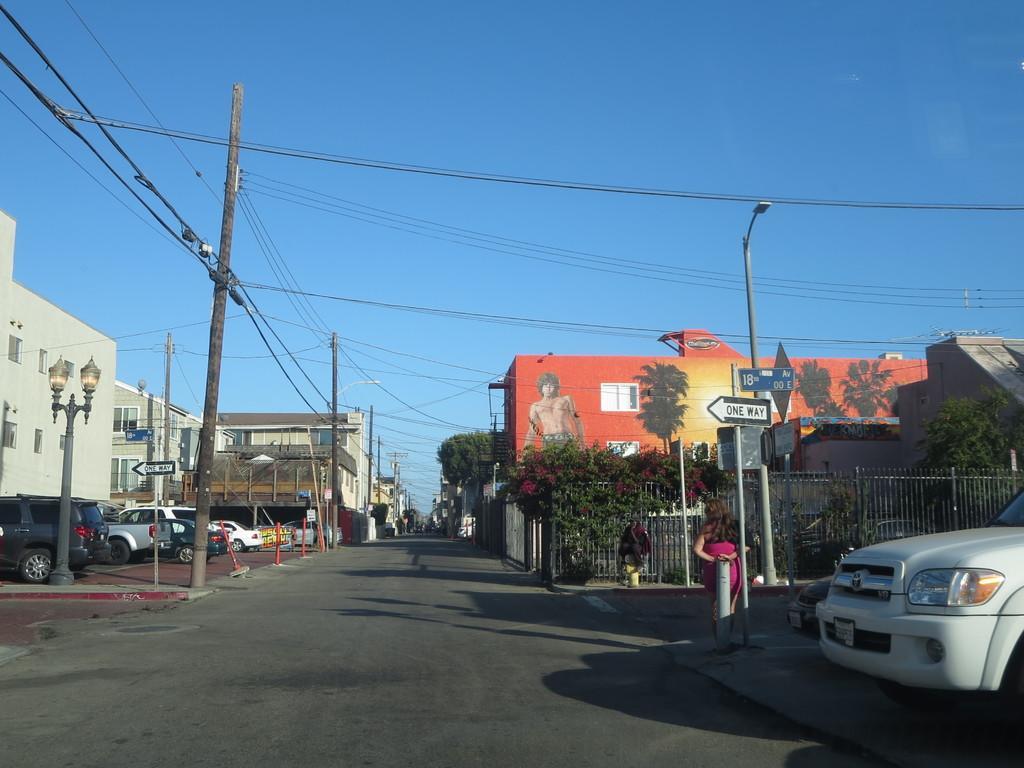How would you summarize this image in a sentence or two? In the right side a car is parked, in the left side there are buildings, at the top it's a sunny sky. 